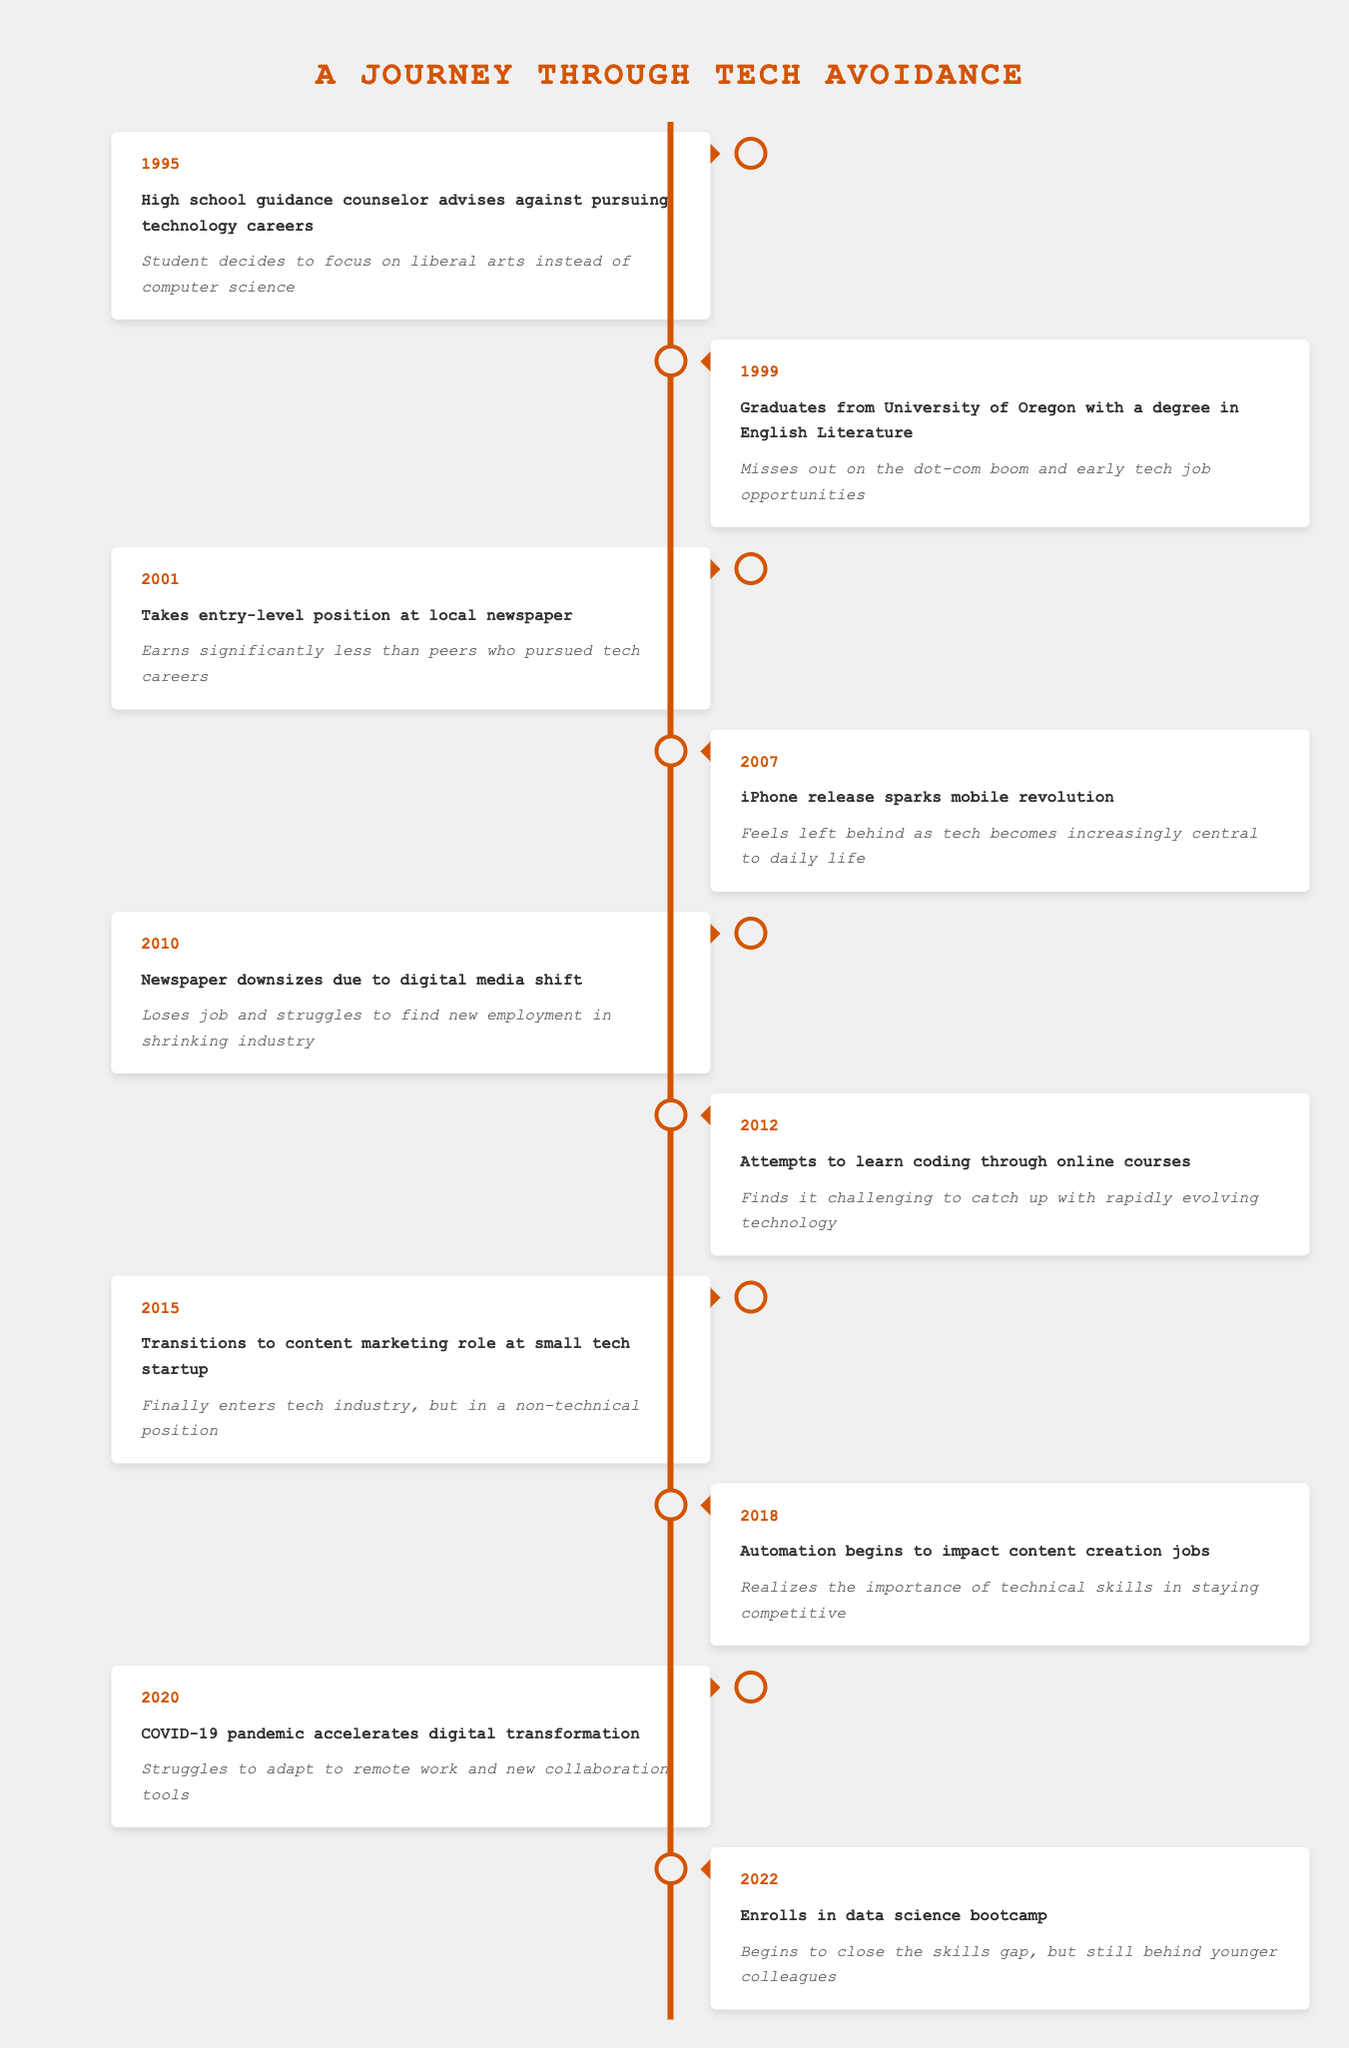What year did the student take an entry-level position at a local newspaper? The row for the entry-level position at a local newspaper indicates the event year as 2001.
Answer: 2001 What impact did the guidance counselor's advice have on the student's career? The event from 1995 states that the student decided to focus on liberal arts instead of computer science after receiving guidance against pursuing technology careers.
Answer: Focus on liberal arts How many years did it take from graduating to entering the tech industry at a startup? The student graduated in 1999 and transitioned to a content marketing role in 2015. The difference is 2015 - 1999 = 16 years.
Answer: 16 years Did the student ever face job loss due to changes in the media industry? Yes, in 2010 the newspaper downsized due to a shift to digital media, leading to job loss.
Answer: Yes What was the primary reason for feeling left behind during the mobile revolution? The iPhone release in 2007 marked the beginning of a mobile revolution, and the impact stated that the student felt left behind as tech became central to life.
Answer: Feeling left behind What new skills did the student attempt to acquire in 2012? In 2012, the student attempted to learn coding through online courses but found it challenging due to the rapidly changing technology.
Answer: Learn coding What realization did the student come to in 2018 regarding technical skills? The 2018 event indicates that the student realized the importance of technical skills in staying competitive due to automation impacting content creation jobs.
Answer: Importance of technical skills How many major life events are listed in the table? By counting each event listed in the data, there are a total of 10 major life events from 1995 to 2022.
Answer: 10 events In what year did the student enroll in a data science bootcamp? The final listed event indicates that the student enrolled in a data science bootcamp in 2022.
Answer: 2022 